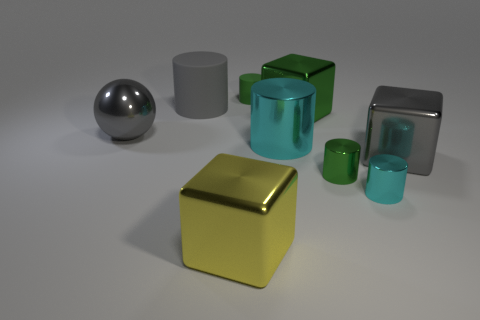Subtract all green metallic blocks. How many blocks are left? 2 Subtract all gray spheres. How many green cylinders are left? 2 Subtract all gray cylinders. How many cylinders are left? 4 Subtract all blue cubes. Subtract all purple cylinders. How many cubes are left? 3 Subtract all cylinders. How many objects are left? 4 Subtract all big cubes. Subtract all small blocks. How many objects are left? 6 Add 5 big gray matte objects. How many big gray matte objects are left? 6 Add 8 large cyan cylinders. How many large cyan cylinders exist? 9 Subtract 1 yellow blocks. How many objects are left? 8 